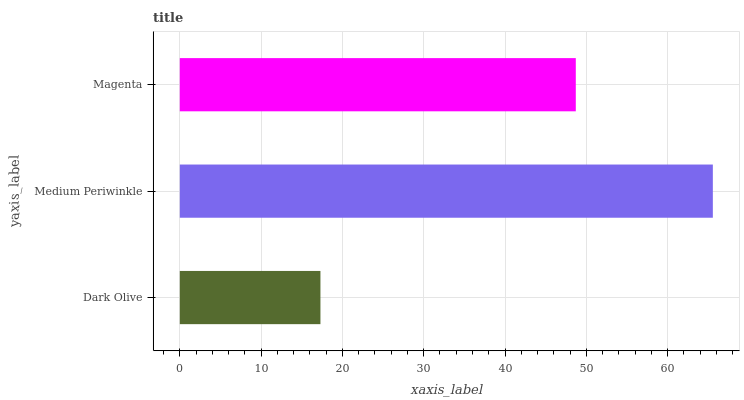Is Dark Olive the minimum?
Answer yes or no. Yes. Is Medium Periwinkle the maximum?
Answer yes or no. Yes. Is Magenta the minimum?
Answer yes or no. No. Is Magenta the maximum?
Answer yes or no. No. Is Medium Periwinkle greater than Magenta?
Answer yes or no. Yes. Is Magenta less than Medium Periwinkle?
Answer yes or no. Yes. Is Magenta greater than Medium Periwinkle?
Answer yes or no. No. Is Medium Periwinkle less than Magenta?
Answer yes or no. No. Is Magenta the high median?
Answer yes or no. Yes. Is Magenta the low median?
Answer yes or no. Yes. Is Medium Periwinkle the high median?
Answer yes or no. No. Is Medium Periwinkle the low median?
Answer yes or no. No. 